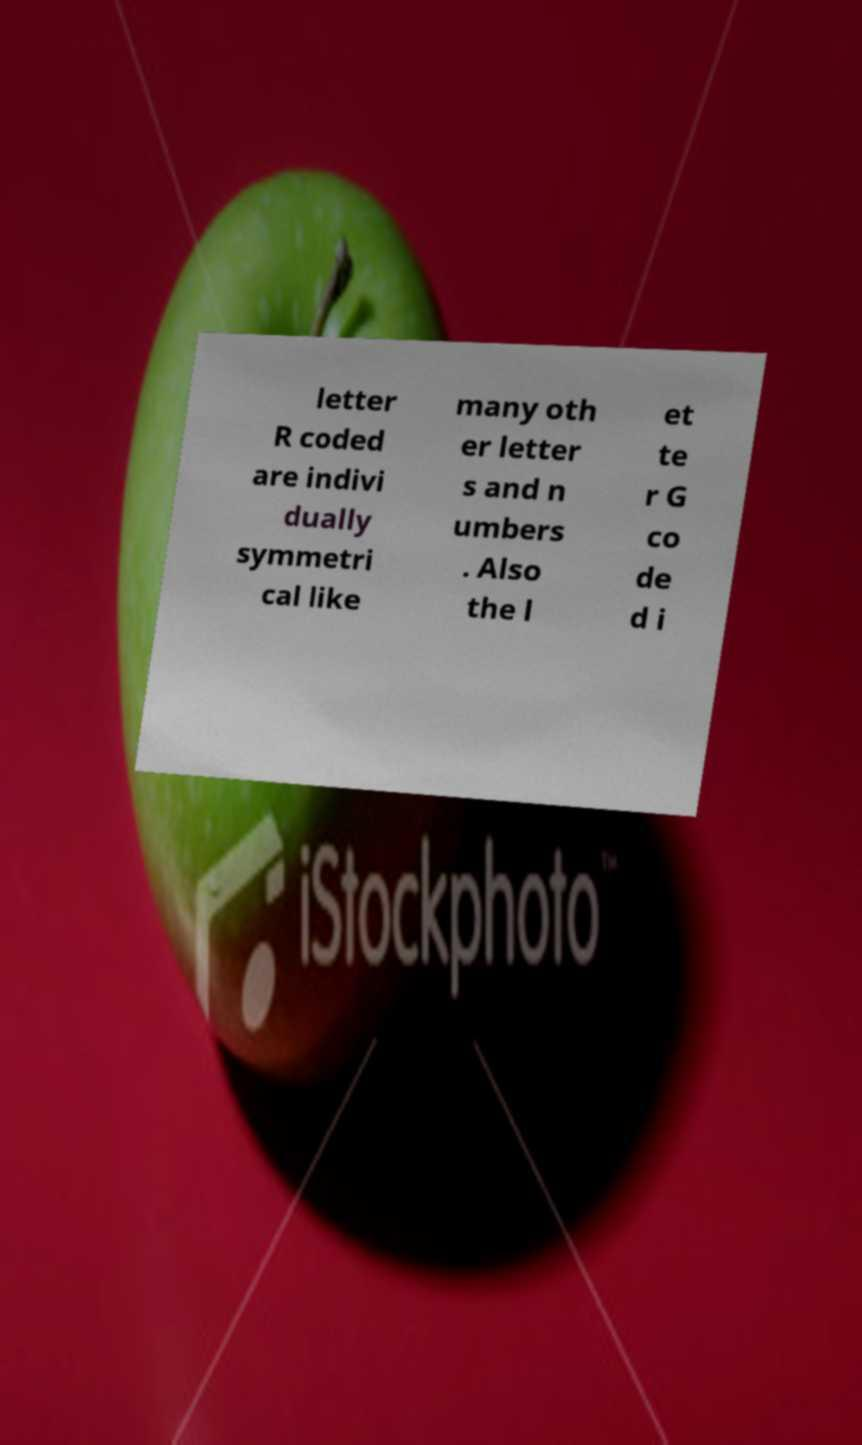What messages or text are displayed in this image? I need them in a readable, typed format. letter R coded are indivi dually symmetri cal like many oth er letter s and n umbers . Also the l et te r G co de d i 